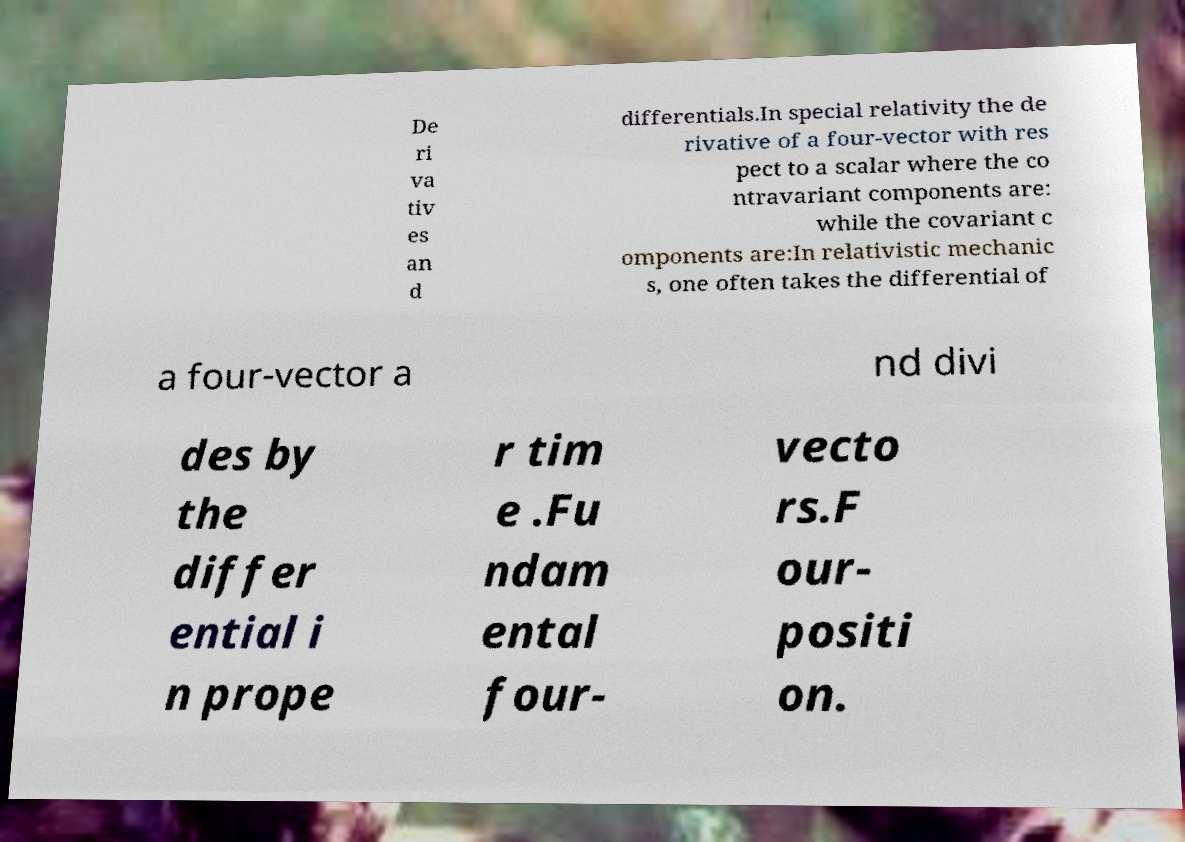Please read and relay the text visible in this image. What does it say? De ri va tiv es an d differentials.In special relativity the de rivative of a four-vector with res pect to a scalar where the co ntravariant components are: while the covariant c omponents are:In relativistic mechanic s, one often takes the differential of a four-vector a nd divi des by the differ ential i n prope r tim e .Fu ndam ental four- vecto rs.F our- positi on. 